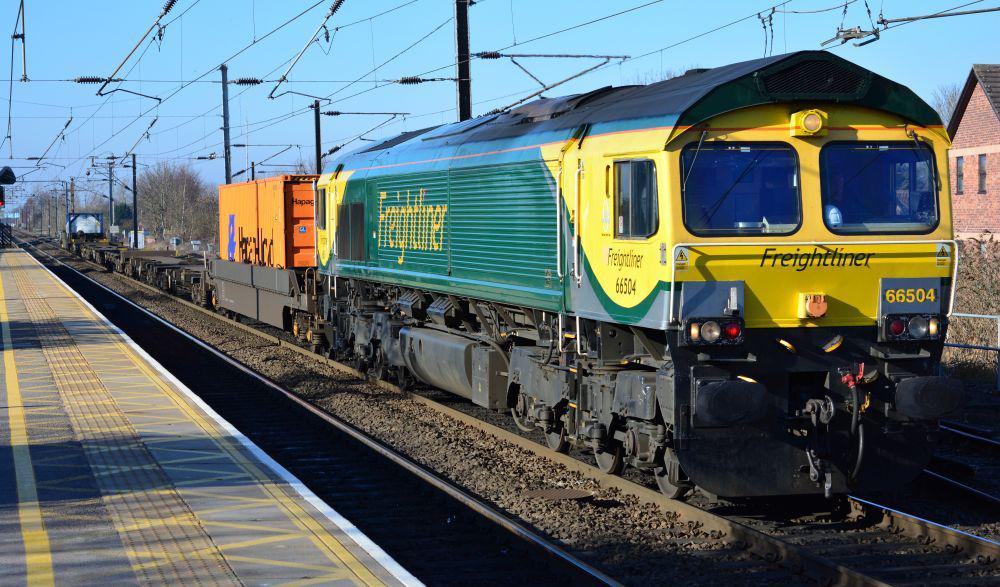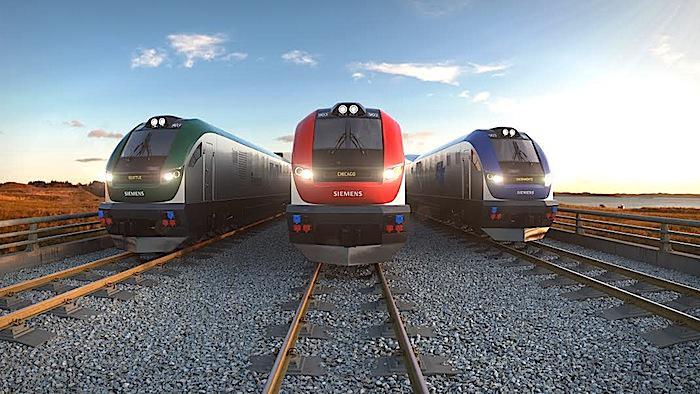The first image is the image on the left, the second image is the image on the right. For the images displayed, is the sentence "Multiple tracks are visible in the left image." factually correct? Answer yes or no. No. The first image is the image on the left, the second image is the image on the right. Given the left and right images, does the statement "in at least one image a train has headlights on" hold true? Answer yes or no. Yes. 